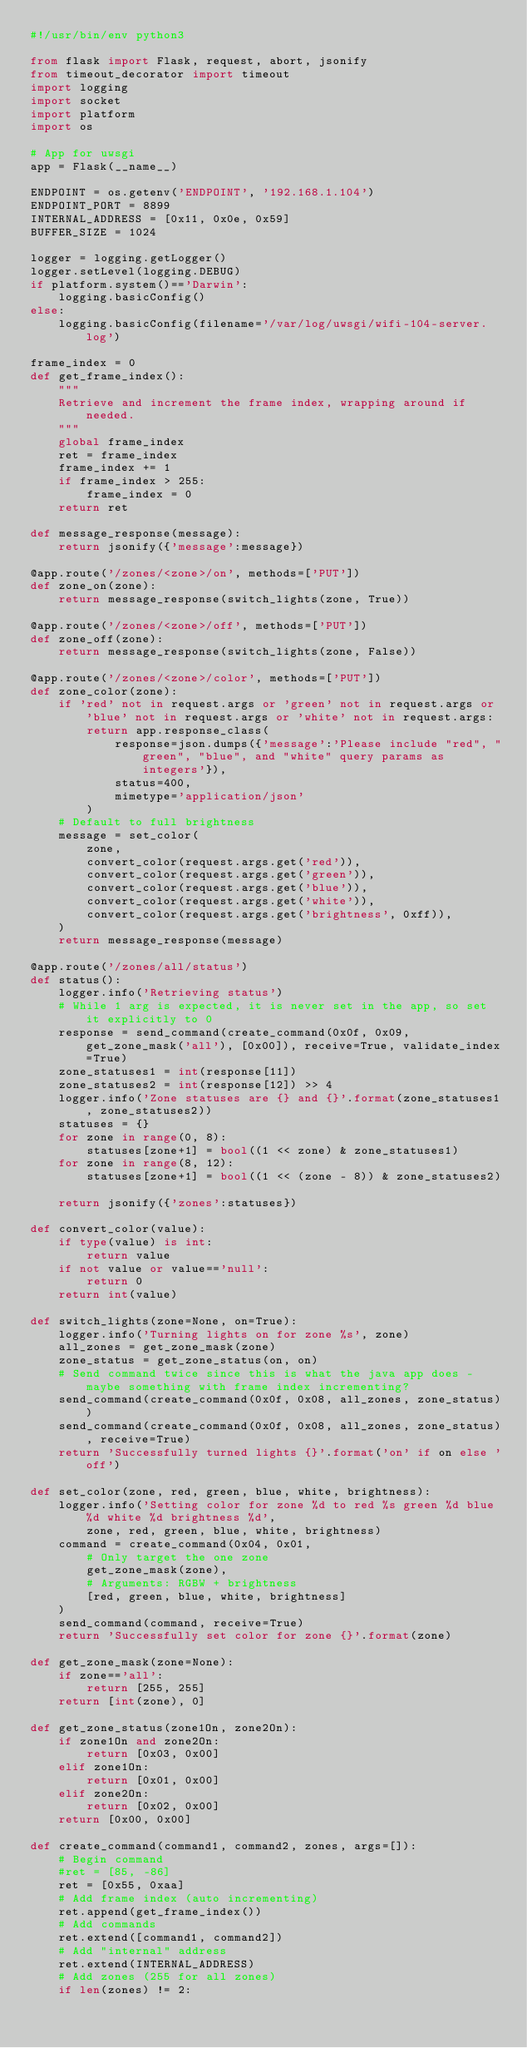Convert code to text. <code><loc_0><loc_0><loc_500><loc_500><_Python_>#!/usr/bin/env python3

from flask import Flask, request, abort, jsonify
from timeout_decorator import timeout
import logging
import socket
import platform
import os

# App for uwsgi
app = Flask(__name__)

ENDPOINT = os.getenv('ENDPOINT', '192.168.1.104')
ENDPOINT_PORT = 8899
INTERNAL_ADDRESS = [0x11, 0x0e, 0x59]
BUFFER_SIZE = 1024

logger = logging.getLogger()
logger.setLevel(logging.DEBUG)
if platform.system()=='Darwin':
    logging.basicConfig()
else:
    logging.basicConfig(filename='/var/log/uwsgi/wifi-104-server.log')

frame_index = 0
def get_frame_index():
    """
    Retrieve and increment the frame index, wrapping around if needed.
    """
    global frame_index
    ret = frame_index
    frame_index += 1
    if frame_index > 255:
        frame_index = 0
    return ret

def message_response(message):
    return jsonify({'message':message})

@app.route('/zones/<zone>/on', methods=['PUT'])
def zone_on(zone):
    return message_response(switch_lights(zone, True))

@app.route('/zones/<zone>/off', methods=['PUT'])
def zone_off(zone):
    return message_response(switch_lights(zone, False))

@app.route('/zones/<zone>/color', methods=['PUT'])
def zone_color(zone):
    if 'red' not in request.args or 'green' not in request.args or 'blue' not in request.args or 'white' not in request.args:
        return app.response_class(
            response=json.dumps({'message':'Please include "red", "green", "blue", and "white" query params as integers'}),
            status=400,
            mimetype='application/json'
        )
    # Default to full brightness
    message = set_color(
        zone,
        convert_color(request.args.get('red')),
        convert_color(request.args.get('green')),
        convert_color(request.args.get('blue')),
        convert_color(request.args.get('white')),
        convert_color(request.args.get('brightness', 0xff)),
    )
    return message_response(message)

@app.route('/zones/all/status')
def status():
    logger.info('Retrieving status')
    # While 1 arg is expected, it is never set in the app, so set it explicitly to 0
    response = send_command(create_command(0x0f, 0x09, get_zone_mask('all'), [0x00]), receive=True, validate_index=True)
    zone_statuses1 = int(response[11])
    zone_statuses2 = int(response[12]) >> 4
    logger.info('Zone statuses are {} and {}'.format(zone_statuses1, zone_statuses2))
    statuses = {}
    for zone in range(0, 8):
        statuses[zone+1] = bool((1 << zone) & zone_statuses1)
    for zone in range(8, 12):
        statuses[zone+1] = bool((1 << (zone - 8)) & zone_statuses2)
    
    return jsonify({'zones':statuses})
    
def convert_color(value):
    if type(value) is int:
        return value
    if not value or value=='null':
        return 0
    return int(value)

def switch_lights(zone=None, on=True):
    logger.info('Turning lights on for zone %s', zone)
    all_zones = get_zone_mask(zone)
    zone_status = get_zone_status(on, on)
    # Send command twice since this is what the java app does - maybe something with frame index incrementing?
    send_command(create_command(0x0f, 0x08, all_zones, zone_status))
    send_command(create_command(0x0f, 0x08, all_zones, zone_status), receive=True)
    return 'Successfully turned lights {}'.format('on' if on else 'off')

def set_color(zone, red, green, blue, white, brightness):
    logger.info('Setting color for zone %d to red %s green %d blue %d white %d brightness %d', 
        zone, red, green, blue, white, brightness)
    command = create_command(0x04, 0x01,
        # Only target the one zone
        get_zone_mask(zone),
        # Arguments: RGBW + brightness
        [red, green, blue, white, brightness]
    )
    send_command(command, receive=True)
    return 'Successfully set color for zone {}'.format(zone)

def get_zone_mask(zone=None):
    if zone=='all':
        return [255, 255]
    return [int(zone), 0]

def get_zone_status(zone1On, zone2On):
    if zone1On and zone2On:
        return [0x03, 0x00]
    elif zone1On:
        return [0x01, 0x00]
    elif zone2On:
        return [0x02, 0x00]
    return [0x00, 0x00]

def create_command(command1, command2, zones, args=[]):
    # Begin command
    #ret = [85, -86]
    ret = [0x55, 0xaa]
    # Add frame index (auto incrementing)
    ret.append(get_frame_index())
    # Add commands
    ret.extend([command1, command2])
    # Add "internal" address
    ret.extend(INTERNAL_ADDRESS)
    # Add zones (255 for all zones)
    if len(zones) != 2:</code> 